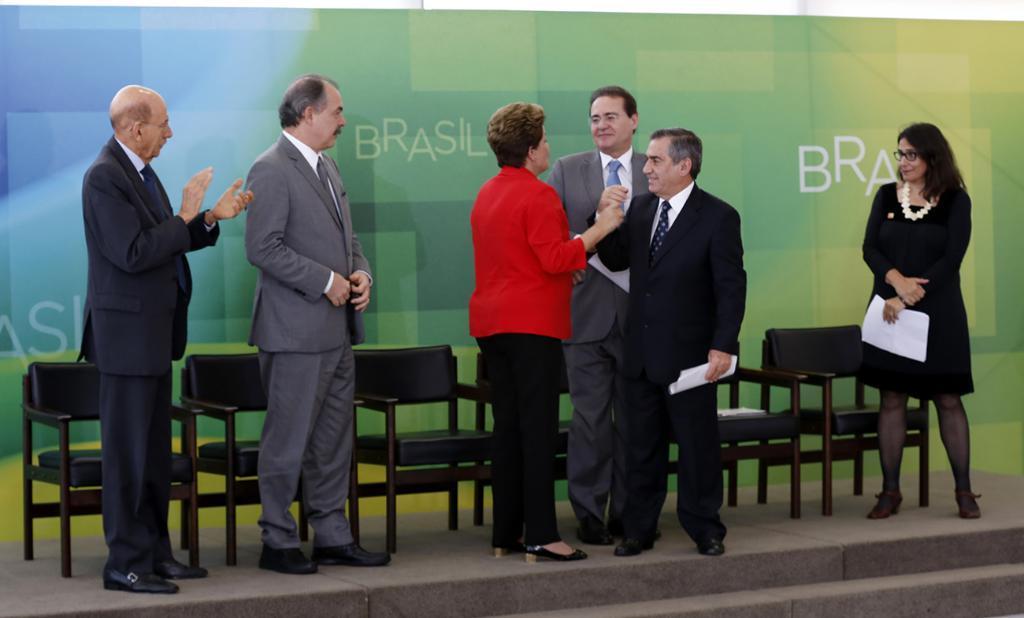Describe this image in one or two sentences. In this picture there is a woman who is wearing red jacket and shoe. She is standing near to the man who is wearing black suit, trouser and shoe. He is also holding a paper. On the right there is another woman who is wearing black dress, locket, spectacle and shoe. She is also holding papers. On the left there are two person standing near to the chairs. Here we can see another man who is wearing grey suit, spectacle, trouser and shoe, standing near to the banner. On the bottom we can see stairs. 